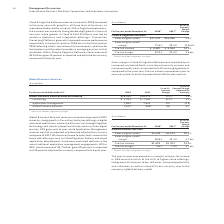According to International Business Machines's financial document, What impacted the Gross margin in Cloud & Cognitive Software? impacted by an increased mix toward SaaS, a mix toward security services and increased royalty costs associated with IP licensing agreements compared to the prior year. The document states: "Gross margin in Cloud & Cognitive Software was impacted by an increased mix toward SaaS, a mix toward security services and increased royalty costs as..." Also, What drove the Pre-tax income improvement? primarily driven by operational efficiencies and mix.. The document states: "year. Pre-tax income improvement year to year was primarily driven by operational efficiencies and mix...." Also, What was the gross profit margin in 2018? According to the financial document, 77.6%. The relevant text states: "External gross profit margin 77.6% 78.1% (0.5) pts...." Also, can you calculate: What is the increase / (decrease) in the external gross profit from 2017 to 2018? Based on the calculation: 17,224 - 16,986, the result is 238 (in millions). This is based on the information: "External gross profit $17,224 $16,986 1.4% External gross profit $17,224 $16,986 1.4%..." The key data points involved are: 16,986, 17,224. Also, can you calculate: What is the average Pre-tax income? To answer this question, I need to perform calculations using the financial data. The calculation is: (8,882 + 8,068) / 2, which equals 8475 (in millions). This is based on the information: "Pre-tax income $ 8,882 $ 8,068 10.1% Pre-tax income $ 8,882 $ 8,068 10.1%..." The key data points involved are: 8,068, 8,882. Also, can you calculate: What is the increase / (decrease) in the Pre-tax margin from 2017 to 2018? Based on the calculation: 35.0% - 32.4%, the result is 2.6 (percentage). This is based on the information: "Pre-tax margin 35.0% 32.4% 2.6 pts. Pre-tax margin 35.0% 32.4% 2.6 pts...." The key data points involved are: 32.4, 35.0. 